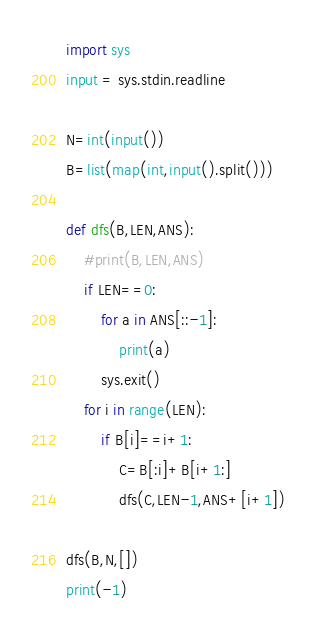Convert code to text. <code><loc_0><loc_0><loc_500><loc_500><_Python_>import sys
input = sys.stdin.readline

N=int(input())
B=list(map(int,input().split()))

def dfs(B,LEN,ANS):
    #print(B,LEN,ANS)
    if LEN==0:
        for a in ANS[::-1]:
            print(a)
        sys.exit()
    for i in range(LEN):
        if B[i]==i+1:
            C=B[:i]+B[i+1:]
            dfs(C,LEN-1,ANS+[i+1])

dfs(B,N,[])
print(-1)</code> 